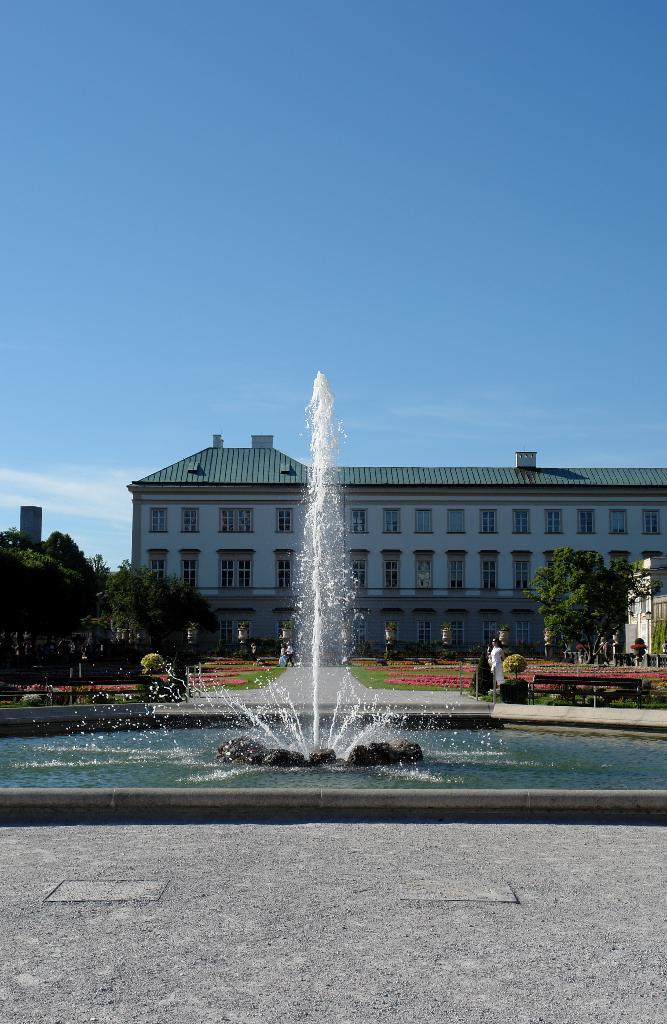What is the main feature in the image? There is a water fountain in the image. What can be seen on the right side of the image? There is a bench on the right side of the image. What type of vegetation is present in the image? There are trees in the image. What type of structures can be seen in the image? There are buildings in the image. Who or what else is present in the image? There are people in the image. What is visible in the background of the image? The sky is visible in the background of the image. What type of stem can be seen growing from the water fountain in the image? There is no stem growing from the water fountain in the image. How many family members are present in the image? There is no indication of a family in the image, so it cannot be determined how many family members are present. 